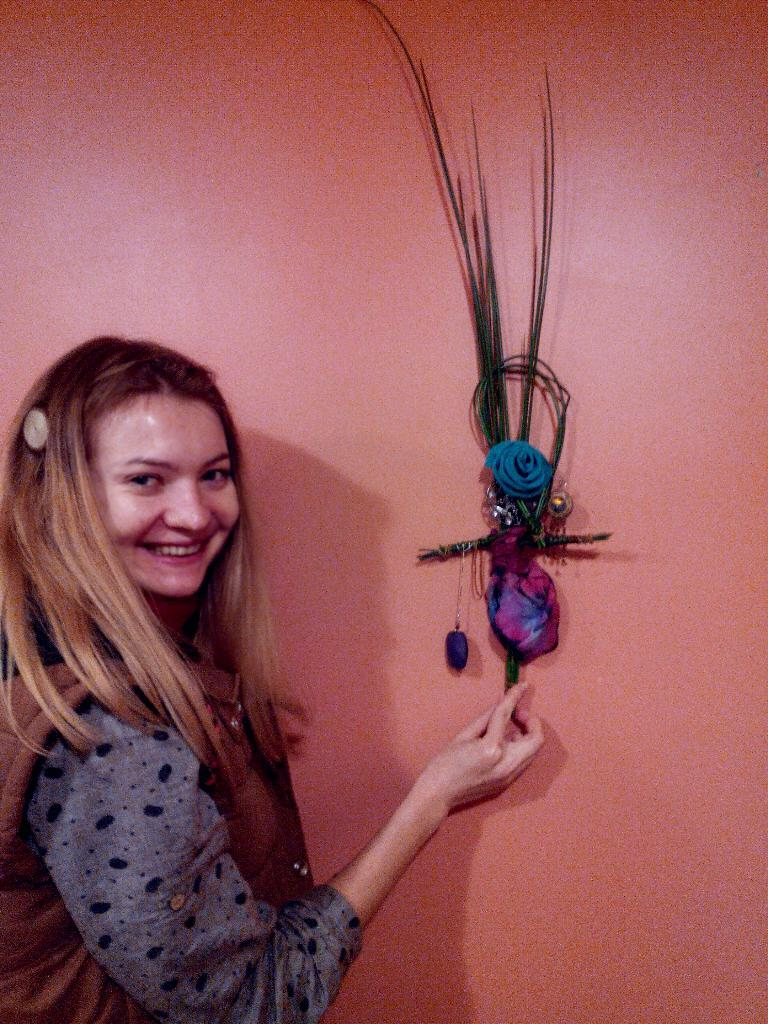Who is present in the image? There is a woman in the image. What is the woman doing in the image? The woman is smiling and looking at something. What is the woman holding in the image? She is holding a decorative piece. What can be seen in the background of the image? There is a wall in the background of the image. What type of songs can be heard in the background of the image? There are no songs present in the image; it is a still photograph. 